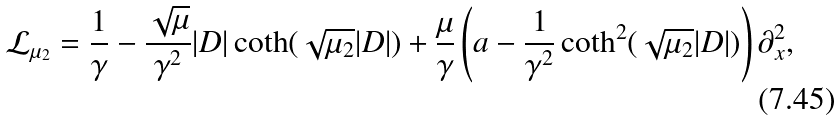<formula> <loc_0><loc_0><loc_500><loc_500>\mathcal { L } _ { \mu _ { 2 } } = \frac { 1 } { \gamma } - \frac { \sqrt { \mu } } { \gamma ^ { 2 } } | D | \coth ( \sqrt { \mu _ { 2 } } | D | ) + \frac { \mu } { \gamma } \left ( a - \frac { 1 } { \gamma ^ { 2 } } \coth ^ { 2 } ( \sqrt { \mu _ { 2 } } | D | ) \right ) \partial _ { x } ^ { 2 } ,</formula> 